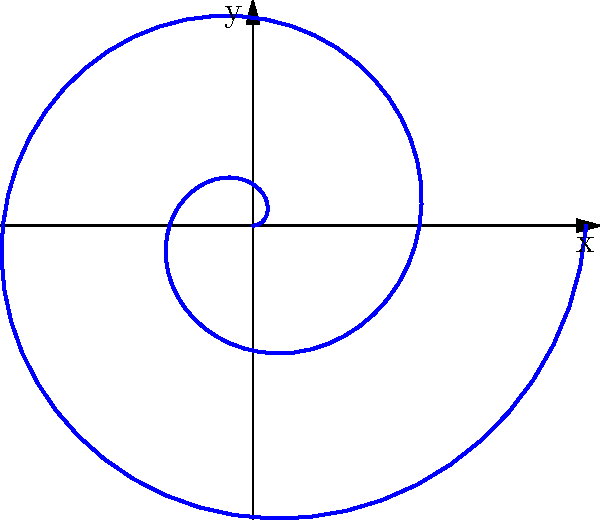You're designing a wallpaper inspired by a sci-fi TV show featuring a spiral galaxy. To create this effect, you decide to use a polar equation. If the equation for the spiral is given by $r = 0.1\theta$, where $r$ is the radius and $\theta$ is the angle in radians, what is the maximum value of $r$ when $\theta$ ranges from 0 to $4\pi$? To find the maximum value of $r$, we need to follow these steps:

1. Understand the given equation: $r = 0.1\theta$

2. Determine the range of $\theta$:
   $0 \leq \theta \leq 4\pi$

3. Calculate the maximum value of $r$:
   - The maximum value of $r$ will occur at the maximum value of $\theta$, which is $4\pi$
   - Substitute $\theta = 4\pi$ into the equation:
     $r_{max} = 0.1 \cdot 4\pi$

4. Simplify the calculation:
   $r_{max} = 0.4\pi$

5. If needed, we can approximate this value:
   $r_{max} \approx 1.257$

Therefore, the maximum value of $r$ is $0.4\pi$ or approximately 1.257 units.
Answer: $0.4\pi$ 